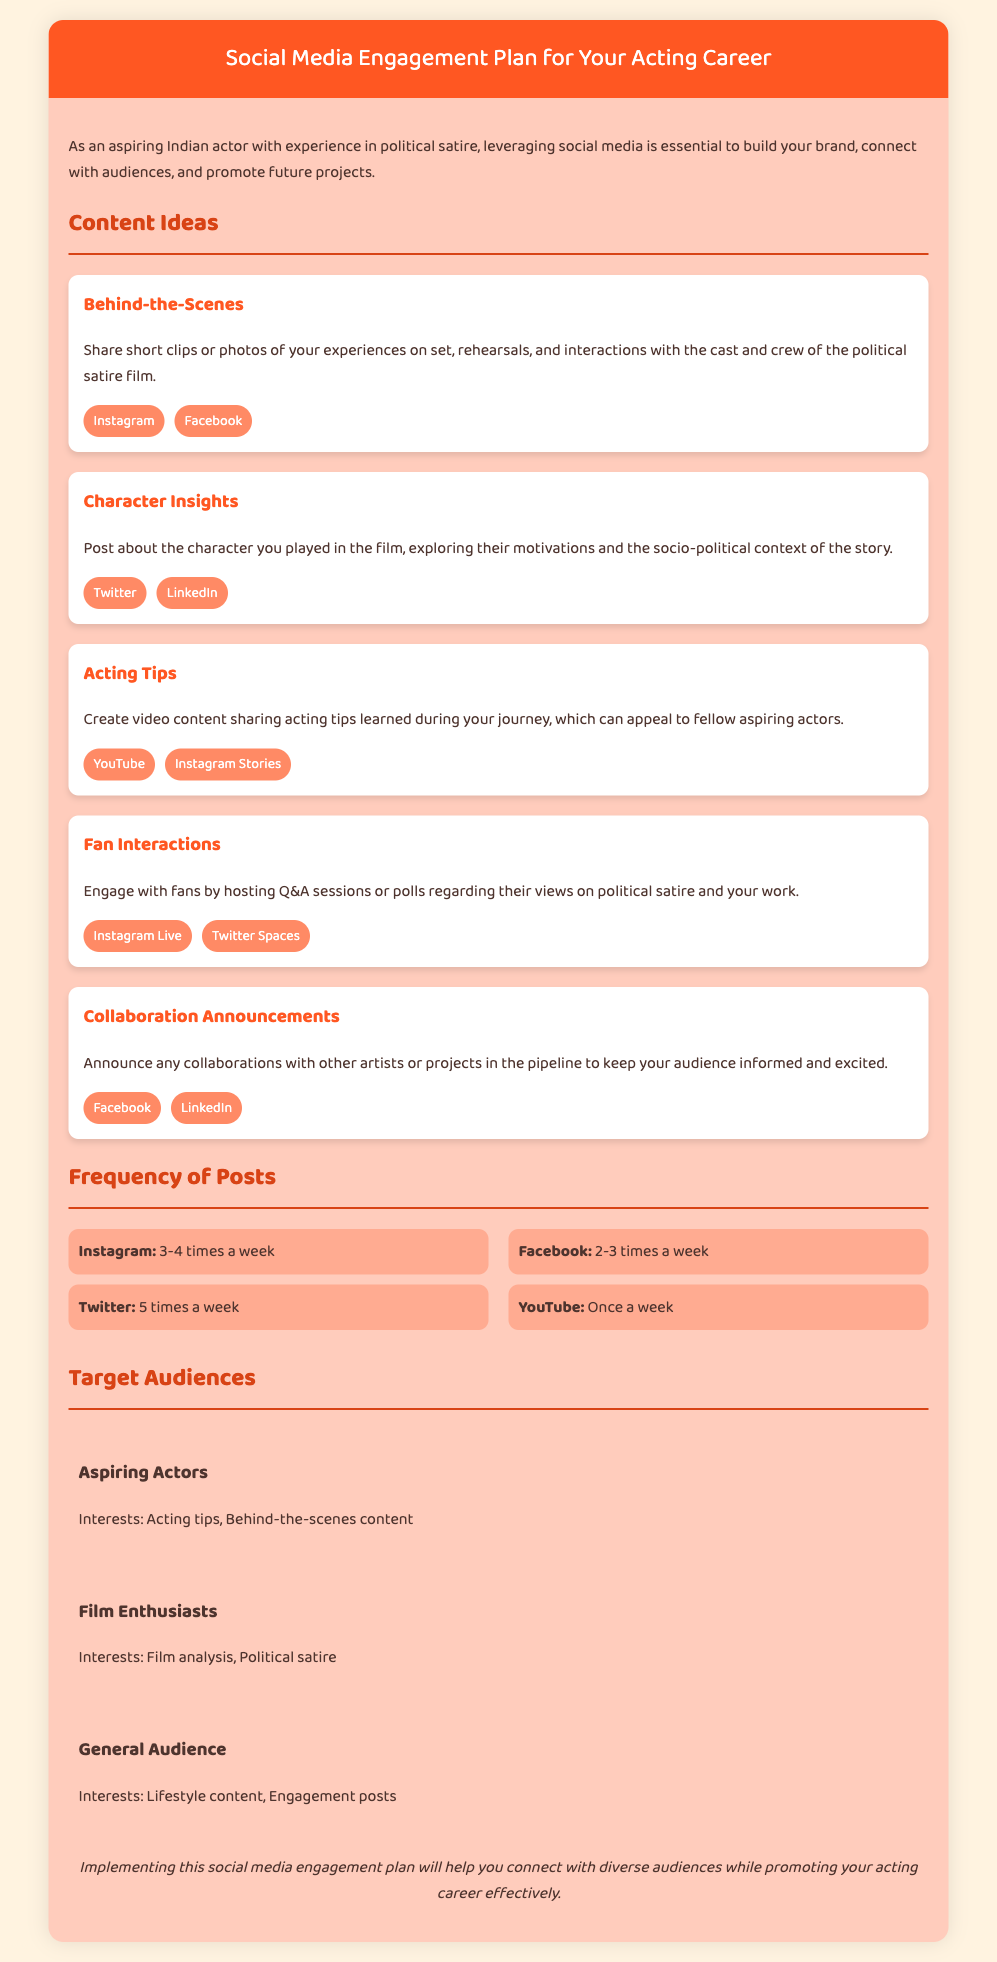what is the title of the document? The title is specified in the document header.
Answer: Social Media Engagement Plan for Your Acting Career how often should you post on Instagram? The document specifies a frequency for Instagram posts.
Answer: 3-4 times a week what type of content is shared in "Behind-the-Scenes"? The document describes the type of content associated with this section.
Answer: Short clips or photos who is the target audience interested in acting tips? The document lists specific target audiences with their interests.
Answer: Aspiring Actors which platforms are suggested for character insights? The document lists platforms associated with character insights.
Answer: Twitter, LinkedIn how often should you post on YouTube? The document specifies the frequency for YouTube posts.
Answer: Once a week what is a suggested content idea for fan interactions? The document mentions specific activities for fan interactions.
Answer: Hosting Q&A sessions what is a key focus of the collaboration announcements? The document indicates what should be communicated in collaboration announcements.
Answer: Upcoming projects 